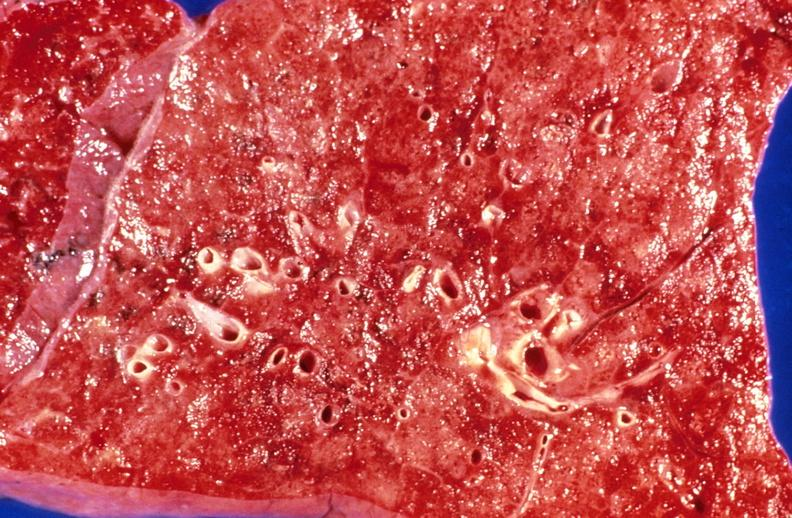s respiratory present?
Answer the question using a single word or phrase. Yes 